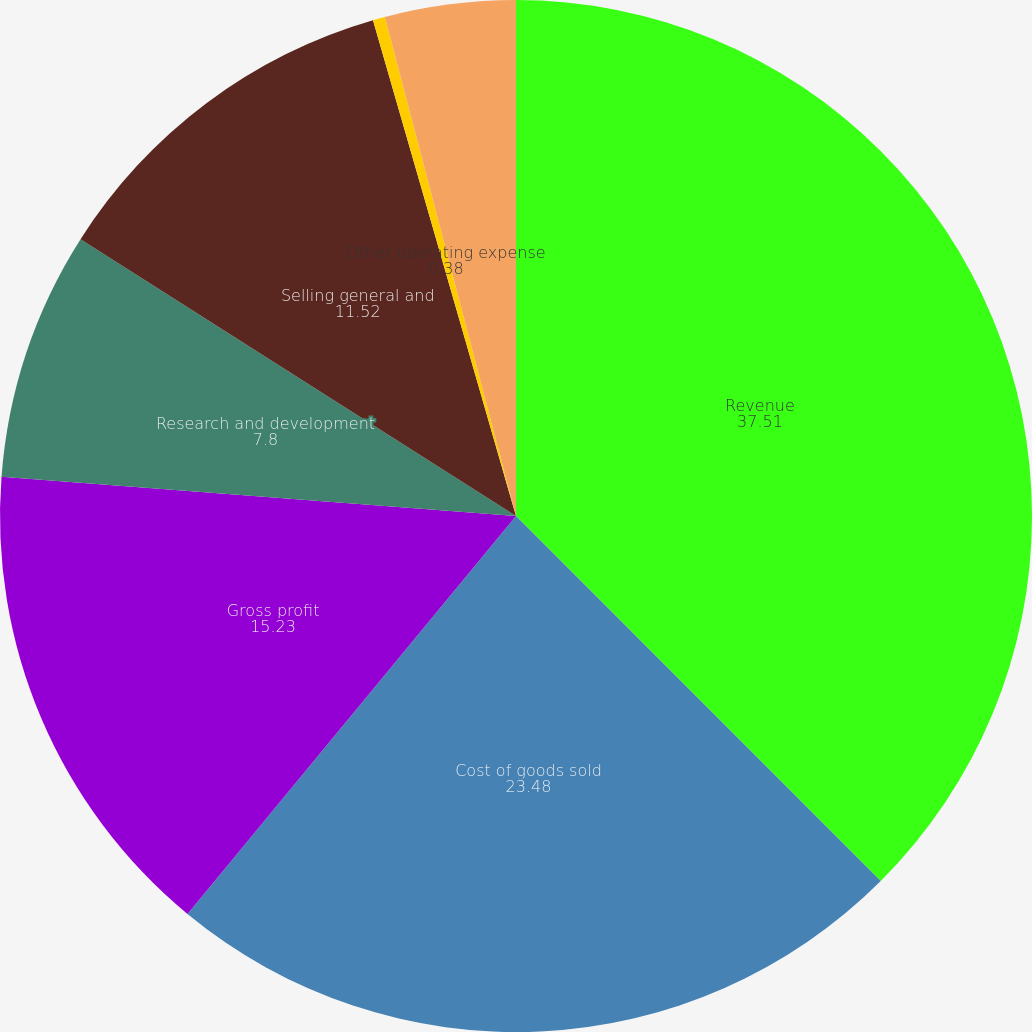<chart> <loc_0><loc_0><loc_500><loc_500><pie_chart><fcel>Revenue<fcel>Cost of goods sold<fcel>Gross profit<fcel>Research and development<fcel>Selling general and<fcel>Other operating expense<fcel>Operating income<nl><fcel>37.51%<fcel>23.48%<fcel>15.23%<fcel>7.8%<fcel>11.52%<fcel>0.38%<fcel>4.09%<nl></chart> 